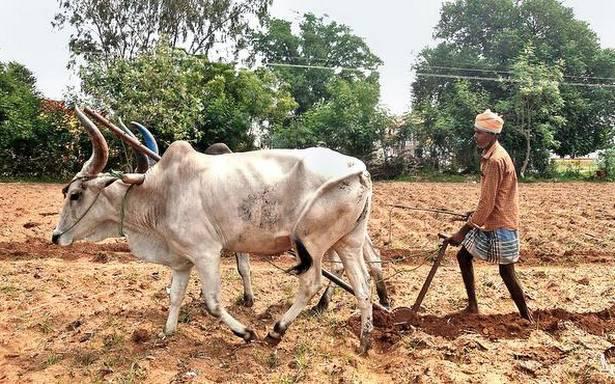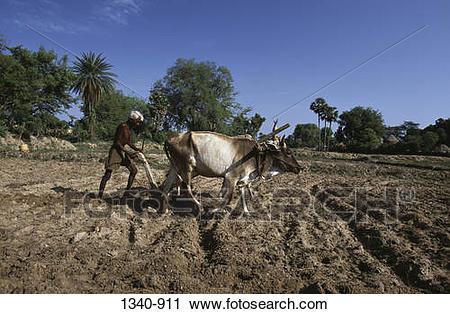The first image is the image on the left, the second image is the image on the right. Examine the images to the left and right. Is the description "Each image shows one person behind two hitched white oxen, and the right image shows oxen moving leftward." accurate? Answer yes or no. No. The first image is the image on the left, the second image is the image on the right. Examine the images to the left and right. Is the description "The left and right image contains the same number of ox pulling a tilt guided by at man and one of the men is not wearing a hat." accurate? Answer yes or no. No. 